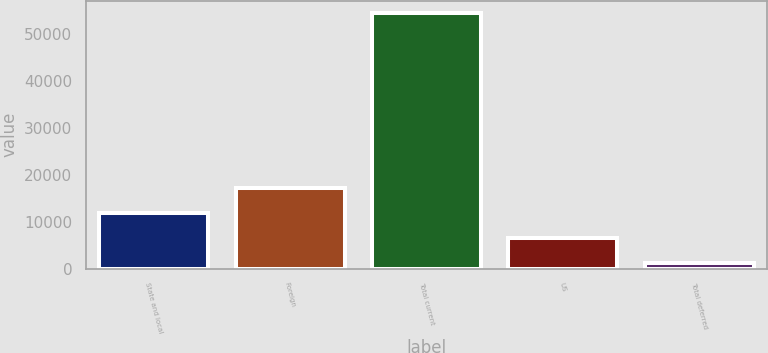<chart> <loc_0><loc_0><loc_500><loc_500><bar_chart><fcel>State and local<fcel>Foreign<fcel>Total current<fcel>US<fcel>Total deferred<nl><fcel>11735.8<fcel>17063.2<fcel>54355<fcel>6408.4<fcel>1081<nl></chart> 